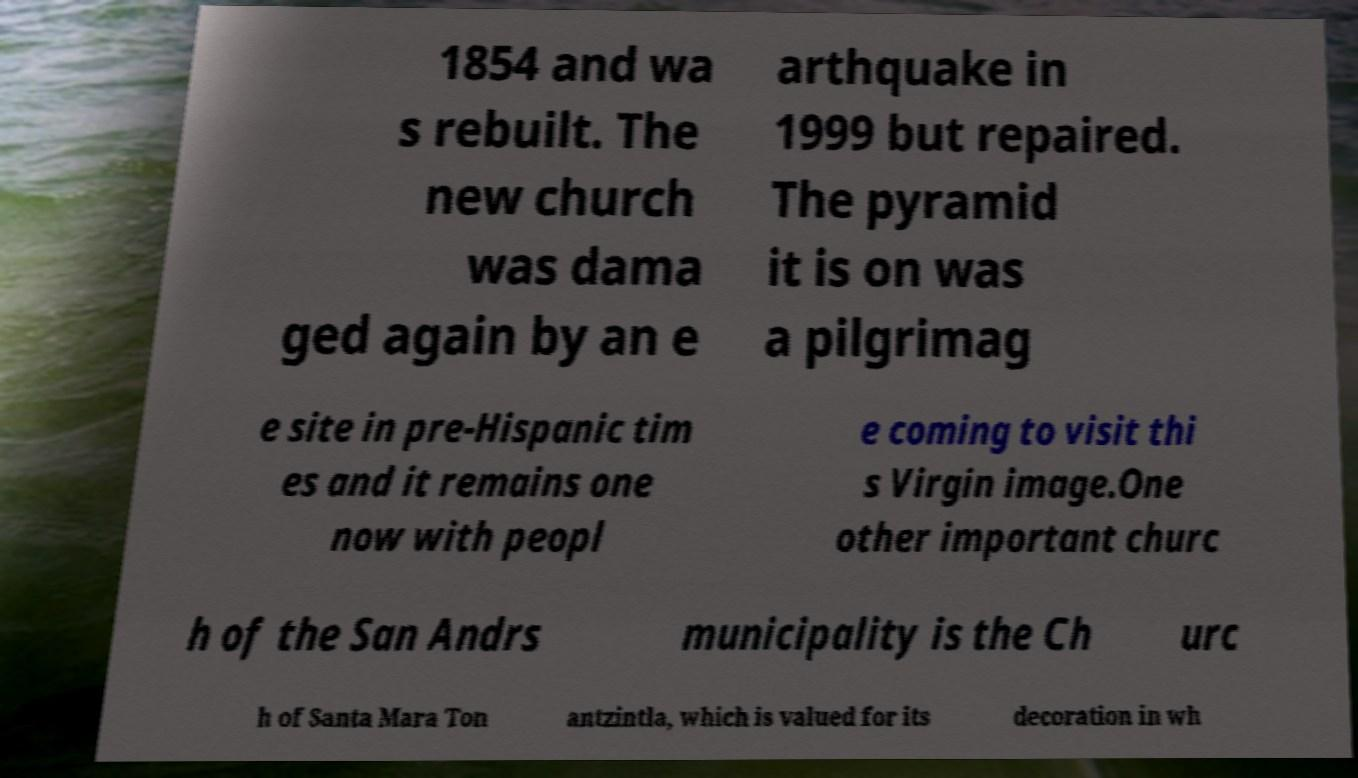Could you extract and type out the text from this image? 1854 and wa s rebuilt. The new church was dama ged again by an e arthquake in 1999 but repaired. The pyramid it is on was a pilgrimag e site in pre-Hispanic tim es and it remains one now with peopl e coming to visit thi s Virgin image.One other important churc h of the San Andrs municipality is the Ch urc h of Santa Mara Ton antzintla, which is valued for its decoration in wh 